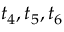<formula> <loc_0><loc_0><loc_500><loc_500>t _ { 4 } , t _ { 5 } , t _ { 6 }</formula> 